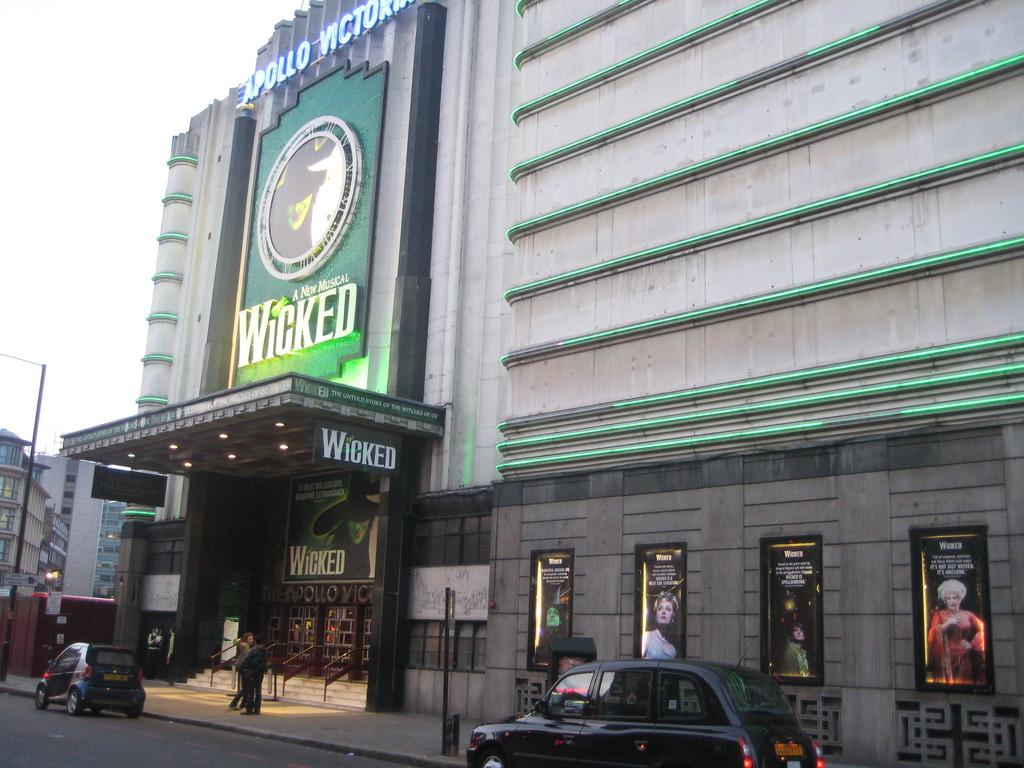What is the theatre showing?
Your answer should be compact. Wicked. What theater is wicked playing at?
Keep it short and to the point. Apollo. 